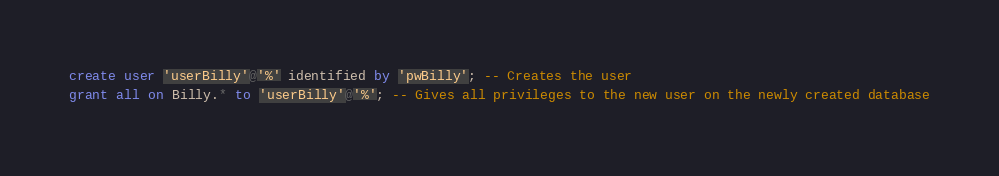<code> <loc_0><loc_0><loc_500><loc_500><_SQL_>create user 'userBilly'@'%' identified by 'pwBilly'; -- Creates the user
grant all on Billy.* to 'userBilly'@'%'; -- Gives all privileges to the new user on the newly created database</code> 